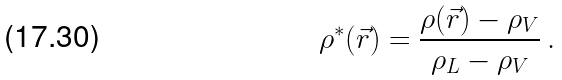<formula> <loc_0><loc_0><loc_500><loc_500>\rho ^ { \ast } ( \vec { r } ) = \frac { \rho ( \vec { r } ) - \rho _ { V } } { \rho _ { L } - \rho _ { V } } \, .</formula> 